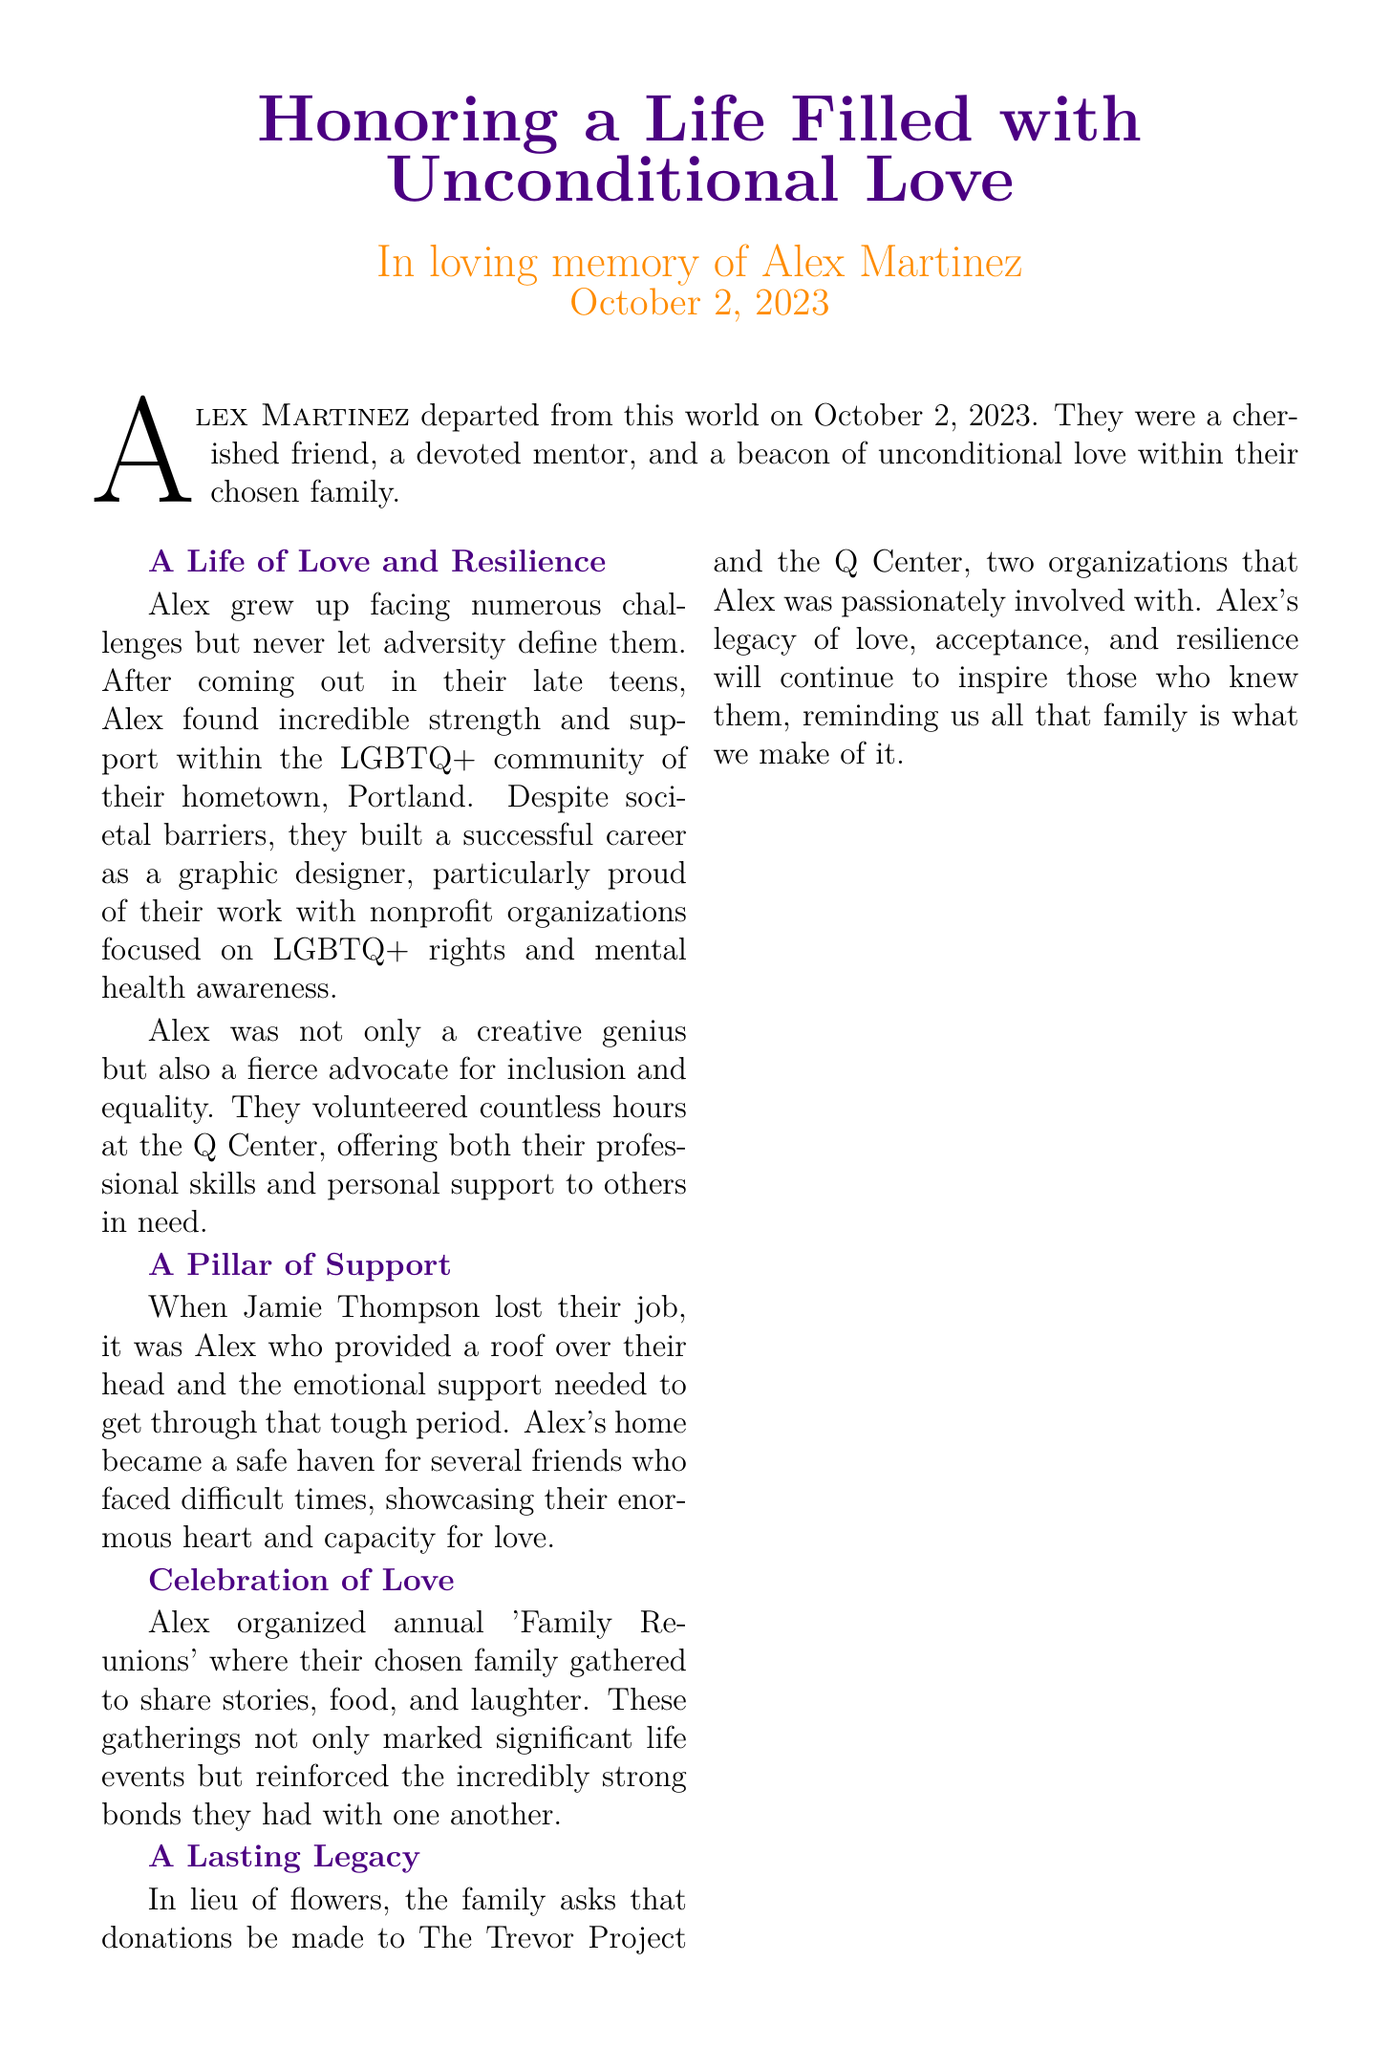What date did Alex Martinez pass away? The document states that Alex Martinez departed from this world on October 2, 2023.
Answer: October 2, 2023 Who provided support to Jamie Thompson during a tough period? The document mentions that it was Alex who provided a roof over Jamie's head and emotional support.
Answer: Alex What was Alex's profession? The obituary states that Alex built a successful career as a graphic designer.
Answer: Graphic designer Which organizations does the family suggest for donations in lieu of flowers? The document mentions The Trevor Project and the Q Center.
Answer: The Trevor Project and the Q Center What did Alex organize annually for their chosen family? The text states that Alex organized annual 'Family Reunions'.
Answer: Family Reunions Why is Alex described as a beacon of unconditional love? The document states that Alex was a cherished friend, a devoted mentor, and a beacon of unconditional love within their chosen family, showcasing their enormous heart.
Answer: Unconditional love What was a characteristic behavior of Alex during difficult times for friends? The text highlights Alex's home became a safe haven for friends facing difficult times.
Answer: Safe haven Who referred to Alex's laughter as "the glue" for the family? The document quotes Samira Patel, a close friend, regarding Alex's laughter.
Answer: Samira Patel 